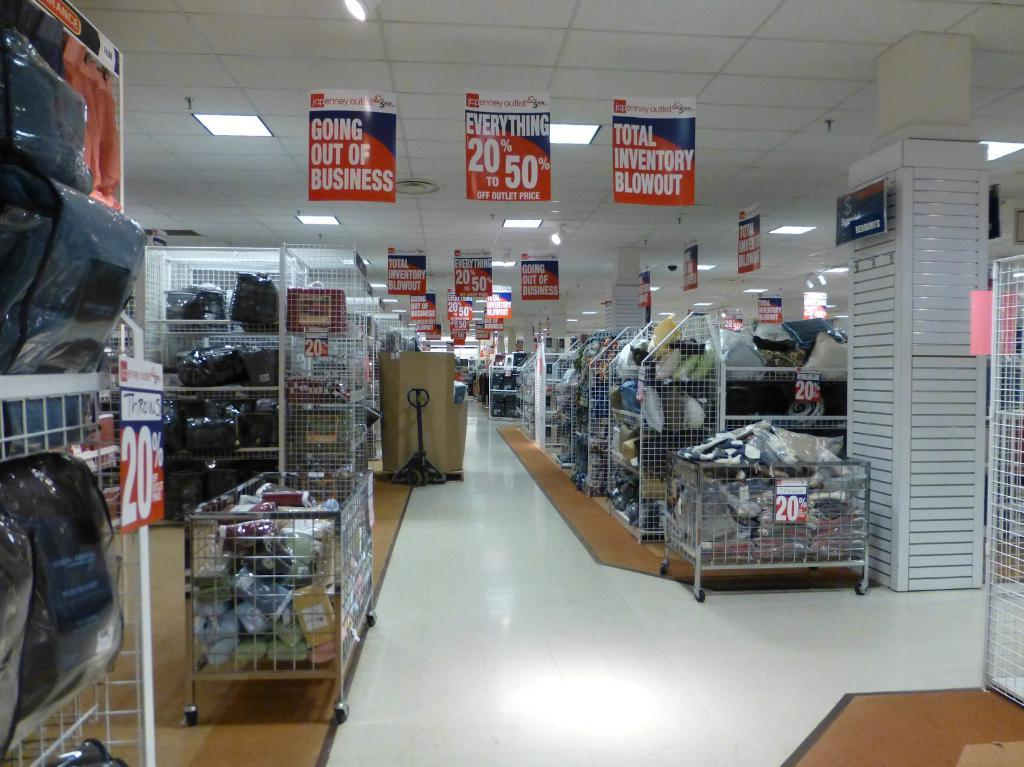Where was the image taken? The image was taken in a store. What can be seen in the store? There are racks, bags, a machine, boxes, various objects, banners, and lighting visible in the image. What is the floor like in the store? The floor is visible in the image. What is at the top of the image? There are banners, lighting, and a ceiling visible at the top of the image. What type of nation is depicted on the banner in the image? There is: There is no nation depicted on the banner in the image. What appliance is being used by the beetle in the image? There are no beetles or appliances present in the image. 